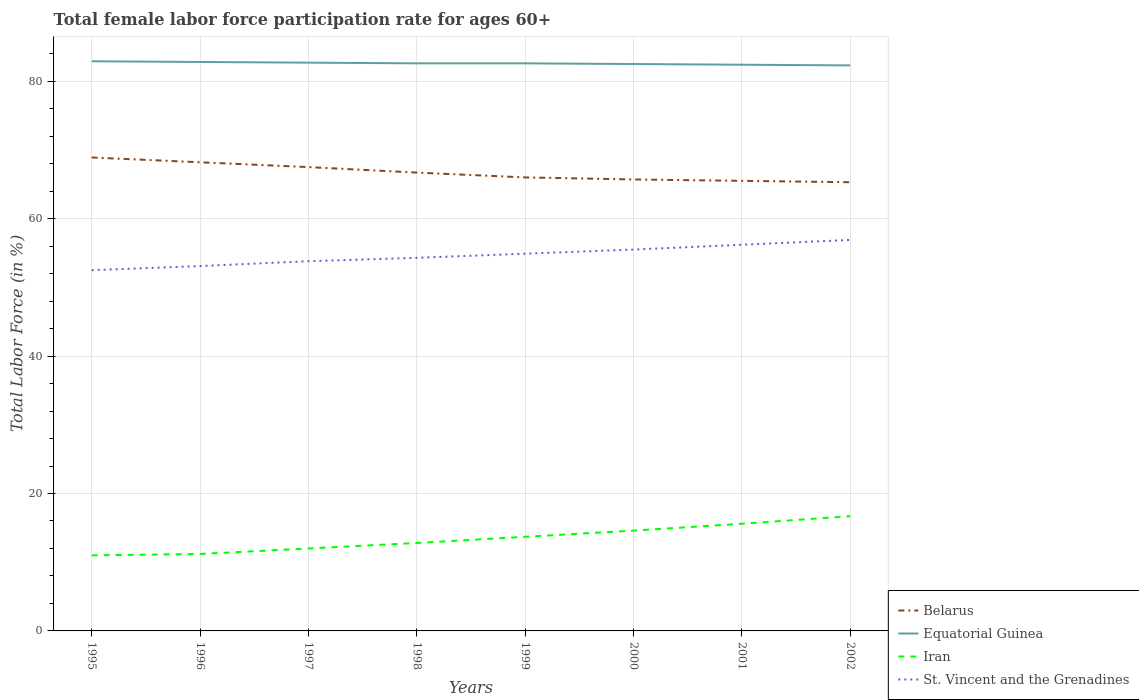How many different coloured lines are there?
Give a very brief answer. 4. Does the line corresponding to Iran intersect with the line corresponding to Belarus?
Provide a succinct answer. No. Is the number of lines equal to the number of legend labels?
Your response must be concise. Yes. Across all years, what is the maximum female labor force participation rate in Belarus?
Offer a terse response. 65.3. What is the total female labor force participation rate in St. Vincent and the Grenadines in the graph?
Provide a short and direct response. -0.6. What is the difference between the highest and the second highest female labor force participation rate in Equatorial Guinea?
Ensure brevity in your answer.  0.6. Is the female labor force participation rate in Equatorial Guinea strictly greater than the female labor force participation rate in St. Vincent and the Grenadines over the years?
Offer a very short reply. No. Are the values on the major ticks of Y-axis written in scientific E-notation?
Make the answer very short. No. Where does the legend appear in the graph?
Offer a very short reply. Bottom right. What is the title of the graph?
Ensure brevity in your answer.  Total female labor force participation rate for ages 60+. Does "South Sudan" appear as one of the legend labels in the graph?
Your answer should be very brief. No. What is the label or title of the Y-axis?
Provide a short and direct response. Total Labor Force (in %). What is the Total Labor Force (in %) of Belarus in 1995?
Offer a very short reply. 68.9. What is the Total Labor Force (in %) in Equatorial Guinea in 1995?
Give a very brief answer. 82.9. What is the Total Labor Force (in %) in Iran in 1995?
Offer a very short reply. 11. What is the Total Labor Force (in %) of St. Vincent and the Grenadines in 1995?
Your response must be concise. 52.5. What is the Total Labor Force (in %) of Belarus in 1996?
Make the answer very short. 68.2. What is the Total Labor Force (in %) in Equatorial Guinea in 1996?
Offer a terse response. 82.8. What is the Total Labor Force (in %) in Iran in 1996?
Keep it short and to the point. 11.2. What is the Total Labor Force (in %) of St. Vincent and the Grenadines in 1996?
Provide a short and direct response. 53.1. What is the Total Labor Force (in %) of Belarus in 1997?
Your answer should be compact. 67.5. What is the Total Labor Force (in %) of Equatorial Guinea in 1997?
Give a very brief answer. 82.7. What is the Total Labor Force (in %) in St. Vincent and the Grenadines in 1997?
Provide a succinct answer. 53.8. What is the Total Labor Force (in %) of Belarus in 1998?
Keep it short and to the point. 66.7. What is the Total Labor Force (in %) in Equatorial Guinea in 1998?
Ensure brevity in your answer.  82.6. What is the Total Labor Force (in %) in Iran in 1998?
Your answer should be compact. 12.8. What is the Total Labor Force (in %) of St. Vincent and the Grenadines in 1998?
Give a very brief answer. 54.3. What is the Total Labor Force (in %) in Equatorial Guinea in 1999?
Give a very brief answer. 82.6. What is the Total Labor Force (in %) of Iran in 1999?
Ensure brevity in your answer.  13.7. What is the Total Labor Force (in %) in St. Vincent and the Grenadines in 1999?
Offer a very short reply. 54.9. What is the Total Labor Force (in %) in Belarus in 2000?
Your response must be concise. 65.7. What is the Total Labor Force (in %) of Equatorial Guinea in 2000?
Your answer should be very brief. 82.5. What is the Total Labor Force (in %) of Iran in 2000?
Ensure brevity in your answer.  14.6. What is the Total Labor Force (in %) of St. Vincent and the Grenadines in 2000?
Offer a very short reply. 55.5. What is the Total Labor Force (in %) in Belarus in 2001?
Offer a terse response. 65.5. What is the Total Labor Force (in %) of Equatorial Guinea in 2001?
Your answer should be very brief. 82.4. What is the Total Labor Force (in %) in Iran in 2001?
Ensure brevity in your answer.  15.6. What is the Total Labor Force (in %) in St. Vincent and the Grenadines in 2001?
Your answer should be compact. 56.2. What is the Total Labor Force (in %) in Belarus in 2002?
Keep it short and to the point. 65.3. What is the Total Labor Force (in %) of Equatorial Guinea in 2002?
Provide a short and direct response. 82.3. What is the Total Labor Force (in %) of Iran in 2002?
Your answer should be compact. 16.7. What is the Total Labor Force (in %) in St. Vincent and the Grenadines in 2002?
Your answer should be very brief. 56.9. Across all years, what is the maximum Total Labor Force (in %) of Belarus?
Make the answer very short. 68.9. Across all years, what is the maximum Total Labor Force (in %) of Equatorial Guinea?
Offer a terse response. 82.9. Across all years, what is the maximum Total Labor Force (in %) of Iran?
Keep it short and to the point. 16.7. Across all years, what is the maximum Total Labor Force (in %) of St. Vincent and the Grenadines?
Ensure brevity in your answer.  56.9. Across all years, what is the minimum Total Labor Force (in %) of Belarus?
Ensure brevity in your answer.  65.3. Across all years, what is the minimum Total Labor Force (in %) in Equatorial Guinea?
Provide a succinct answer. 82.3. Across all years, what is the minimum Total Labor Force (in %) of St. Vincent and the Grenadines?
Offer a terse response. 52.5. What is the total Total Labor Force (in %) in Belarus in the graph?
Provide a succinct answer. 533.8. What is the total Total Labor Force (in %) of Equatorial Guinea in the graph?
Offer a very short reply. 660.8. What is the total Total Labor Force (in %) of Iran in the graph?
Offer a very short reply. 107.6. What is the total Total Labor Force (in %) in St. Vincent and the Grenadines in the graph?
Give a very brief answer. 437.2. What is the difference between the Total Labor Force (in %) of Equatorial Guinea in 1995 and that in 1997?
Provide a short and direct response. 0.2. What is the difference between the Total Labor Force (in %) in Iran in 1995 and that in 1997?
Make the answer very short. -1. What is the difference between the Total Labor Force (in %) of St. Vincent and the Grenadines in 1995 and that in 1997?
Make the answer very short. -1.3. What is the difference between the Total Labor Force (in %) in Iran in 1995 and that in 1998?
Provide a short and direct response. -1.8. What is the difference between the Total Labor Force (in %) in Equatorial Guinea in 1995 and that in 1999?
Keep it short and to the point. 0.3. What is the difference between the Total Labor Force (in %) in Iran in 1995 and that in 1999?
Your response must be concise. -2.7. What is the difference between the Total Labor Force (in %) in St. Vincent and the Grenadines in 1995 and that in 1999?
Keep it short and to the point. -2.4. What is the difference between the Total Labor Force (in %) in Iran in 1995 and that in 2000?
Make the answer very short. -3.6. What is the difference between the Total Labor Force (in %) of Belarus in 1995 and that in 2002?
Your answer should be very brief. 3.6. What is the difference between the Total Labor Force (in %) in Iran in 1996 and that in 1998?
Ensure brevity in your answer.  -1.6. What is the difference between the Total Labor Force (in %) of Equatorial Guinea in 1996 and that in 1999?
Ensure brevity in your answer.  0.2. What is the difference between the Total Labor Force (in %) in St. Vincent and the Grenadines in 1996 and that in 1999?
Ensure brevity in your answer.  -1.8. What is the difference between the Total Labor Force (in %) in Iran in 1996 and that in 2000?
Give a very brief answer. -3.4. What is the difference between the Total Labor Force (in %) of St. Vincent and the Grenadines in 1996 and that in 2000?
Offer a very short reply. -2.4. What is the difference between the Total Labor Force (in %) in Belarus in 1996 and that in 2001?
Make the answer very short. 2.7. What is the difference between the Total Labor Force (in %) in St. Vincent and the Grenadines in 1996 and that in 2002?
Provide a short and direct response. -3.8. What is the difference between the Total Labor Force (in %) of Equatorial Guinea in 1997 and that in 1998?
Make the answer very short. 0.1. What is the difference between the Total Labor Force (in %) in Belarus in 1997 and that in 1999?
Make the answer very short. 1.5. What is the difference between the Total Labor Force (in %) in Iran in 1997 and that in 1999?
Make the answer very short. -1.7. What is the difference between the Total Labor Force (in %) in St. Vincent and the Grenadines in 1997 and that in 1999?
Offer a terse response. -1.1. What is the difference between the Total Labor Force (in %) of Iran in 1997 and that in 2000?
Your answer should be very brief. -2.6. What is the difference between the Total Labor Force (in %) in St. Vincent and the Grenadines in 1997 and that in 2000?
Offer a very short reply. -1.7. What is the difference between the Total Labor Force (in %) in Belarus in 1997 and that in 2001?
Provide a succinct answer. 2. What is the difference between the Total Labor Force (in %) in Iran in 1997 and that in 2001?
Your response must be concise. -3.6. What is the difference between the Total Labor Force (in %) in Belarus in 1997 and that in 2002?
Ensure brevity in your answer.  2.2. What is the difference between the Total Labor Force (in %) of St. Vincent and the Grenadines in 1997 and that in 2002?
Provide a succinct answer. -3.1. What is the difference between the Total Labor Force (in %) of Belarus in 1998 and that in 1999?
Provide a short and direct response. 0.7. What is the difference between the Total Labor Force (in %) in Iran in 1998 and that in 1999?
Your response must be concise. -0.9. What is the difference between the Total Labor Force (in %) in St. Vincent and the Grenadines in 1998 and that in 1999?
Give a very brief answer. -0.6. What is the difference between the Total Labor Force (in %) in Belarus in 1998 and that in 2000?
Give a very brief answer. 1. What is the difference between the Total Labor Force (in %) in Equatorial Guinea in 1998 and that in 2000?
Offer a terse response. 0.1. What is the difference between the Total Labor Force (in %) in St. Vincent and the Grenadines in 1998 and that in 2000?
Your response must be concise. -1.2. What is the difference between the Total Labor Force (in %) of Belarus in 1998 and that in 2002?
Provide a short and direct response. 1.4. What is the difference between the Total Labor Force (in %) of Belarus in 1999 and that in 2000?
Give a very brief answer. 0.3. What is the difference between the Total Labor Force (in %) in Iran in 1999 and that in 2000?
Make the answer very short. -0.9. What is the difference between the Total Labor Force (in %) of Belarus in 1999 and that in 2001?
Make the answer very short. 0.5. What is the difference between the Total Labor Force (in %) of Iran in 1999 and that in 2001?
Make the answer very short. -1.9. What is the difference between the Total Labor Force (in %) in Belarus in 1999 and that in 2002?
Offer a terse response. 0.7. What is the difference between the Total Labor Force (in %) of St. Vincent and the Grenadines in 1999 and that in 2002?
Make the answer very short. -2. What is the difference between the Total Labor Force (in %) of Belarus in 2000 and that in 2001?
Provide a short and direct response. 0.2. What is the difference between the Total Labor Force (in %) of Equatorial Guinea in 2000 and that in 2001?
Provide a short and direct response. 0.1. What is the difference between the Total Labor Force (in %) in St. Vincent and the Grenadines in 2000 and that in 2001?
Your answer should be very brief. -0.7. What is the difference between the Total Labor Force (in %) of Belarus in 2000 and that in 2002?
Your answer should be very brief. 0.4. What is the difference between the Total Labor Force (in %) of Equatorial Guinea in 2000 and that in 2002?
Provide a succinct answer. 0.2. What is the difference between the Total Labor Force (in %) of Equatorial Guinea in 2001 and that in 2002?
Ensure brevity in your answer.  0.1. What is the difference between the Total Labor Force (in %) in Belarus in 1995 and the Total Labor Force (in %) in Iran in 1996?
Offer a very short reply. 57.7. What is the difference between the Total Labor Force (in %) in Equatorial Guinea in 1995 and the Total Labor Force (in %) in Iran in 1996?
Your answer should be very brief. 71.7. What is the difference between the Total Labor Force (in %) in Equatorial Guinea in 1995 and the Total Labor Force (in %) in St. Vincent and the Grenadines in 1996?
Offer a very short reply. 29.8. What is the difference between the Total Labor Force (in %) of Iran in 1995 and the Total Labor Force (in %) of St. Vincent and the Grenadines in 1996?
Provide a succinct answer. -42.1. What is the difference between the Total Labor Force (in %) of Belarus in 1995 and the Total Labor Force (in %) of Equatorial Guinea in 1997?
Provide a short and direct response. -13.8. What is the difference between the Total Labor Force (in %) of Belarus in 1995 and the Total Labor Force (in %) of Iran in 1997?
Provide a short and direct response. 56.9. What is the difference between the Total Labor Force (in %) in Belarus in 1995 and the Total Labor Force (in %) in St. Vincent and the Grenadines in 1997?
Give a very brief answer. 15.1. What is the difference between the Total Labor Force (in %) in Equatorial Guinea in 1995 and the Total Labor Force (in %) in Iran in 1997?
Keep it short and to the point. 70.9. What is the difference between the Total Labor Force (in %) of Equatorial Guinea in 1995 and the Total Labor Force (in %) of St. Vincent and the Grenadines in 1997?
Keep it short and to the point. 29.1. What is the difference between the Total Labor Force (in %) of Iran in 1995 and the Total Labor Force (in %) of St. Vincent and the Grenadines in 1997?
Your answer should be very brief. -42.8. What is the difference between the Total Labor Force (in %) of Belarus in 1995 and the Total Labor Force (in %) of Equatorial Guinea in 1998?
Provide a short and direct response. -13.7. What is the difference between the Total Labor Force (in %) in Belarus in 1995 and the Total Labor Force (in %) in Iran in 1998?
Your answer should be compact. 56.1. What is the difference between the Total Labor Force (in %) of Belarus in 1995 and the Total Labor Force (in %) of St. Vincent and the Grenadines in 1998?
Your response must be concise. 14.6. What is the difference between the Total Labor Force (in %) in Equatorial Guinea in 1995 and the Total Labor Force (in %) in Iran in 1998?
Your answer should be compact. 70.1. What is the difference between the Total Labor Force (in %) in Equatorial Guinea in 1995 and the Total Labor Force (in %) in St. Vincent and the Grenadines in 1998?
Offer a terse response. 28.6. What is the difference between the Total Labor Force (in %) in Iran in 1995 and the Total Labor Force (in %) in St. Vincent and the Grenadines in 1998?
Your answer should be compact. -43.3. What is the difference between the Total Labor Force (in %) in Belarus in 1995 and the Total Labor Force (in %) in Equatorial Guinea in 1999?
Your answer should be very brief. -13.7. What is the difference between the Total Labor Force (in %) of Belarus in 1995 and the Total Labor Force (in %) of Iran in 1999?
Ensure brevity in your answer.  55.2. What is the difference between the Total Labor Force (in %) of Equatorial Guinea in 1995 and the Total Labor Force (in %) of Iran in 1999?
Offer a very short reply. 69.2. What is the difference between the Total Labor Force (in %) of Equatorial Guinea in 1995 and the Total Labor Force (in %) of St. Vincent and the Grenadines in 1999?
Provide a short and direct response. 28. What is the difference between the Total Labor Force (in %) of Iran in 1995 and the Total Labor Force (in %) of St. Vincent and the Grenadines in 1999?
Make the answer very short. -43.9. What is the difference between the Total Labor Force (in %) of Belarus in 1995 and the Total Labor Force (in %) of Equatorial Guinea in 2000?
Your answer should be very brief. -13.6. What is the difference between the Total Labor Force (in %) in Belarus in 1995 and the Total Labor Force (in %) in Iran in 2000?
Your answer should be compact. 54.3. What is the difference between the Total Labor Force (in %) in Belarus in 1995 and the Total Labor Force (in %) in St. Vincent and the Grenadines in 2000?
Ensure brevity in your answer.  13.4. What is the difference between the Total Labor Force (in %) in Equatorial Guinea in 1995 and the Total Labor Force (in %) in Iran in 2000?
Ensure brevity in your answer.  68.3. What is the difference between the Total Labor Force (in %) in Equatorial Guinea in 1995 and the Total Labor Force (in %) in St. Vincent and the Grenadines in 2000?
Ensure brevity in your answer.  27.4. What is the difference between the Total Labor Force (in %) in Iran in 1995 and the Total Labor Force (in %) in St. Vincent and the Grenadines in 2000?
Offer a very short reply. -44.5. What is the difference between the Total Labor Force (in %) in Belarus in 1995 and the Total Labor Force (in %) in Equatorial Guinea in 2001?
Offer a terse response. -13.5. What is the difference between the Total Labor Force (in %) of Belarus in 1995 and the Total Labor Force (in %) of Iran in 2001?
Give a very brief answer. 53.3. What is the difference between the Total Labor Force (in %) of Equatorial Guinea in 1995 and the Total Labor Force (in %) of Iran in 2001?
Your answer should be very brief. 67.3. What is the difference between the Total Labor Force (in %) in Equatorial Guinea in 1995 and the Total Labor Force (in %) in St. Vincent and the Grenadines in 2001?
Keep it short and to the point. 26.7. What is the difference between the Total Labor Force (in %) of Iran in 1995 and the Total Labor Force (in %) of St. Vincent and the Grenadines in 2001?
Provide a succinct answer. -45.2. What is the difference between the Total Labor Force (in %) in Belarus in 1995 and the Total Labor Force (in %) in Equatorial Guinea in 2002?
Make the answer very short. -13.4. What is the difference between the Total Labor Force (in %) in Belarus in 1995 and the Total Labor Force (in %) in Iran in 2002?
Keep it short and to the point. 52.2. What is the difference between the Total Labor Force (in %) in Equatorial Guinea in 1995 and the Total Labor Force (in %) in Iran in 2002?
Offer a very short reply. 66.2. What is the difference between the Total Labor Force (in %) of Iran in 1995 and the Total Labor Force (in %) of St. Vincent and the Grenadines in 2002?
Keep it short and to the point. -45.9. What is the difference between the Total Labor Force (in %) in Belarus in 1996 and the Total Labor Force (in %) in Iran in 1997?
Make the answer very short. 56.2. What is the difference between the Total Labor Force (in %) of Equatorial Guinea in 1996 and the Total Labor Force (in %) of Iran in 1997?
Keep it short and to the point. 70.8. What is the difference between the Total Labor Force (in %) in Equatorial Guinea in 1996 and the Total Labor Force (in %) in St. Vincent and the Grenadines in 1997?
Provide a succinct answer. 29. What is the difference between the Total Labor Force (in %) in Iran in 1996 and the Total Labor Force (in %) in St. Vincent and the Grenadines in 1997?
Give a very brief answer. -42.6. What is the difference between the Total Labor Force (in %) of Belarus in 1996 and the Total Labor Force (in %) of Equatorial Guinea in 1998?
Keep it short and to the point. -14.4. What is the difference between the Total Labor Force (in %) of Belarus in 1996 and the Total Labor Force (in %) of Iran in 1998?
Provide a short and direct response. 55.4. What is the difference between the Total Labor Force (in %) in Belarus in 1996 and the Total Labor Force (in %) in St. Vincent and the Grenadines in 1998?
Make the answer very short. 13.9. What is the difference between the Total Labor Force (in %) of Equatorial Guinea in 1996 and the Total Labor Force (in %) of Iran in 1998?
Offer a very short reply. 70. What is the difference between the Total Labor Force (in %) in Iran in 1996 and the Total Labor Force (in %) in St. Vincent and the Grenadines in 1998?
Keep it short and to the point. -43.1. What is the difference between the Total Labor Force (in %) of Belarus in 1996 and the Total Labor Force (in %) of Equatorial Guinea in 1999?
Offer a terse response. -14.4. What is the difference between the Total Labor Force (in %) of Belarus in 1996 and the Total Labor Force (in %) of Iran in 1999?
Make the answer very short. 54.5. What is the difference between the Total Labor Force (in %) of Belarus in 1996 and the Total Labor Force (in %) of St. Vincent and the Grenadines in 1999?
Offer a very short reply. 13.3. What is the difference between the Total Labor Force (in %) in Equatorial Guinea in 1996 and the Total Labor Force (in %) in Iran in 1999?
Ensure brevity in your answer.  69.1. What is the difference between the Total Labor Force (in %) in Equatorial Guinea in 1996 and the Total Labor Force (in %) in St. Vincent and the Grenadines in 1999?
Give a very brief answer. 27.9. What is the difference between the Total Labor Force (in %) of Iran in 1996 and the Total Labor Force (in %) of St. Vincent and the Grenadines in 1999?
Provide a short and direct response. -43.7. What is the difference between the Total Labor Force (in %) of Belarus in 1996 and the Total Labor Force (in %) of Equatorial Guinea in 2000?
Keep it short and to the point. -14.3. What is the difference between the Total Labor Force (in %) of Belarus in 1996 and the Total Labor Force (in %) of Iran in 2000?
Ensure brevity in your answer.  53.6. What is the difference between the Total Labor Force (in %) of Belarus in 1996 and the Total Labor Force (in %) of St. Vincent and the Grenadines in 2000?
Your answer should be compact. 12.7. What is the difference between the Total Labor Force (in %) of Equatorial Guinea in 1996 and the Total Labor Force (in %) of Iran in 2000?
Ensure brevity in your answer.  68.2. What is the difference between the Total Labor Force (in %) in Equatorial Guinea in 1996 and the Total Labor Force (in %) in St. Vincent and the Grenadines in 2000?
Ensure brevity in your answer.  27.3. What is the difference between the Total Labor Force (in %) in Iran in 1996 and the Total Labor Force (in %) in St. Vincent and the Grenadines in 2000?
Make the answer very short. -44.3. What is the difference between the Total Labor Force (in %) of Belarus in 1996 and the Total Labor Force (in %) of Equatorial Guinea in 2001?
Your answer should be very brief. -14.2. What is the difference between the Total Labor Force (in %) of Belarus in 1996 and the Total Labor Force (in %) of Iran in 2001?
Offer a very short reply. 52.6. What is the difference between the Total Labor Force (in %) of Belarus in 1996 and the Total Labor Force (in %) of St. Vincent and the Grenadines in 2001?
Keep it short and to the point. 12. What is the difference between the Total Labor Force (in %) in Equatorial Guinea in 1996 and the Total Labor Force (in %) in Iran in 2001?
Make the answer very short. 67.2. What is the difference between the Total Labor Force (in %) in Equatorial Guinea in 1996 and the Total Labor Force (in %) in St. Vincent and the Grenadines in 2001?
Keep it short and to the point. 26.6. What is the difference between the Total Labor Force (in %) of Iran in 1996 and the Total Labor Force (in %) of St. Vincent and the Grenadines in 2001?
Provide a succinct answer. -45. What is the difference between the Total Labor Force (in %) in Belarus in 1996 and the Total Labor Force (in %) in Equatorial Guinea in 2002?
Make the answer very short. -14.1. What is the difference between the Total Labor Force (in %) in Belarus in 1996 and the Total Labor Force (in %) in Iran in 2002?
Provide a succinct answer. 51.5. What is the difference between the Total Labor Force (in %) in Belarus in 1996 and the Total Labor Force (in %) in St. Vincent and the Grenadines in 2002?
Your response must be concise. 11.3. What is the difference between the Total Labor Force (in %) of Equatorial Guinea in 1996 and the Total Labor Force (in %) of Iran in 2002?
Your answer should be compact. 66.1. What is the difference between the Total Labor Force (in %) in Equatorial Guinea in 1996 and the Total Labor Force (in %) in St. Vincent and the Grenadines in 2002?
Offer a terse response. 25.9. What is the difference between the Total Labor Force (in %) of Iran in 1996 and the Total Labor Force (in %) of St. Vincent and the Grenadines in 2002?
Ensure brevity in your answer.  -45.7. What is the difference between the Total Labor Force (in %) of Belarus in 1997 and the Total Labor Force (in %) of Equatorial Guinea in 1998?
Your answer should be compact. -15.1. What is the difference between the Total Labor Force (in %) of Belarus in 1997 and the Total Labor Force (in %) of Iran in 1998?
Ensure brevity in your answer.  54.7. What is the difference between the Total Labor Force (in %) in Belarus in 1997 and the Total Labor Force (in %) in St. Vincent and the Grenadines in 1998?
Offer a terse response. 13.2. What is the difference between the Total Labor Force (in %) of Equatorial Guinea in 1997 and the Total Labor Force (in %) of Iran in 1998?
Make the answer very short. 69.9. What is the difference between the Total Labor Force (in %) of Equatorial Guinea in 1997 and the Total Labor Force (in %) of St. Vincent and the Grenadines in 1998?
Give a very brief answer. 28.4. What is the difference between the Total Labor Force (in %) in Iran in 1997 and the Total Labor Force (in %) in St. Vincent and the Grenadines in 1998?
Provide a succinct answer. -42.3. What is the difference between the Total Labor Force (in %) in Belarus in 1997 and the Total Labor Force (in %) in Equatorial Guinea in 1999?
Provide a short and direct response. -15.1. What is the difference between the Total Labor Force (in %) of Belarus in 1997 and the Total Labor Force (in %) of Iran in 1999?
Provide a succinct answer. 53.8. What is the difference between the Total Labor Force (in %) of Equatorial Guinea in 1997 and the Total Labor Force (in %) of Iran in 1999?
Give a very brief answer. 69. What is the difference between the Total Labor Force (in %) of Equatorial Guinea in 1997 and the Total Labor Force (in %) of St. Vincent and the Grenadines in 1999?
Your answer should be very brief. 27.8. What is the difference between the Total Labor Force (in %) of Iran in 1997 and the Total Labor Force (in %) of St. Vincent and the Grenadines in 1999?
Keep it short and to the point. -42.9. What is the difference between the Total Labor Force (in %) in Belarus in 1997 and the Total Labor Force (in %) in Iran in 2000?
Keep it short and to the point. 52.9. What is the difference between the Total Labor Force (in %) of Equatorial Guinea in 1997 and the Total Labor Force (in %) of Iran in 2000?
Make the answer very short. 68.1. What is the difference between the Total Labor Force (in %) in Equatorial Guinea in 1997 and the Total Labor Force (in %) in St. Vincent and the Grenadines in 2000?
Offer a terse response. 27.2. What is the difference between the Total Labor Force (in %) of Iran in 1997 and the Total Labor Force (in %) of St. Vincent and the Grenadines in 2000?
Your answer should be compact. -43.5. What is the difference between the Total Labor Force (in %) of Belarus in 1997 and the Total Labor Force (in %) of Equatorial Guinea in 2001?
Provide a short and direct response. -14.9. What is the difference between the Total Labor Force (in %) in Belarus in 1997 and the Total Labor Force (in %) in Iran in 2001?
Your answer should be very brief. 51.9. What is the difference between the Total Labor Force (in %) of Belarus in 1997 and the Total Labor Force (in %) of St. Vincent and the Grenadines in 2001?
Ensure brevity in your answer.  11.3. What is the difference between the Total Labor Force (in %) in Equatorial Guinea in 1997 and the Total Labor Force (in %) in Iran in 2001?
Your response must be concise. 67.1. What is the difference between the Total Labor Force (in %) in Equatorial Guinea in 1997 and the Total Labor Force (in %) in St. Vincent and the Grenadines in 2001?
Offer a terse response. 26.5. What is the difference between the Total Labor Force (in %) in Iran in 1997 and the Total Labor Force (in %) in St. Vincent and the Grenadines in 2001?
Provide a short and direct response. -44.2. What is the difference between the Total Labor Force (in %) in Belarus in 1997 and the Total Labor Force (in %) in Equatorial Guinea in 2002?
Your answer should be compact. -14.8. What is the difference between the Total Labor Force (in %) in Belarus in 1997 and the Total Labor Force (in %) in Iran in 2002?
Keep it short and to the point. 50.8. What is the difference between the Total Labor Force (in %) in Belarus in 1997 and the Total Labor Force (in %) in St. Vincent and the Grenadines in 2002?
Give a very brief answer. 10.6. What is the difference between the Total Labor Force (in %) in Equatorial Guinea in 1997 and the Total Labor Force (in %) in St. Vincent and the Grenadines in 2002?
Keep it short and to the point. 25.8. What is the difference between the Total Labor Force (in %) in Iran in 1997 and the Total Labor Force (in %) in St. Vincent and the Grenadines in 2002?
Keep it short and to the point. -44.9. What is the difference between the Total Labor Force (in %) in Belarus in 1998 and the Total Labor Force (in %) in Equatorial Guinea in 1999?
Ensure brevity in your answer.  -15.9. What is the difference between the Total Labor Force (in %) of Belarus in 1998 and the Total Labor Force (in %) of Iran in 1999?
Offer a terse response. 53. What is the difference between the Total Labor Force (in %) in Belarus in 1998 and the Total Labor Force (in %) in St. Vincent and the Grenadines in 1999?
Offer a very short reply. 11.8. What is the difference between the Total Labor Force (in %) in Equatorial Guinea in 1998 and the Total Labor Force (in %) in Iran in 1999?
Ensure brevity in your answer.  68.9. What is the difference between the Total Labor Force (in %) of Equatorial Guinea in 1998 and the Total Labor Force (in %) of St. Vincent and the Grenadines in 1999?
Keep it short and to the point. 27.7. What is the difference between the Total Labor Force (in %) in Iran in 1998 and the Total Labor Force (in %) in St. Vincent and the Grenadines in 1999?
Offer a terse response. -42.1. What is the difference between the Total Labor Force (in %) of Belarus in 1998 and the Total Labor Force (in %) of Equatorial Guinea in 2000?
Give a very brief answer. -15.8. What is the difference between the Total Labor Force (in %) in Belarus in 1998 and the Total Labor Force (in %) in Iran in 2000?
Provide a short and direct response. 52.1. What is the difference between the Total Labor Force (in %) of Equatorial Guinea in 1998 and the Total Labor Force (in %) of Iran in 2000?
Provide a short and direct response. 68. What is the difference between the Total Labor Force (in %) of Equatorial Guinea in 1998 and the Total Labor Force (in %) of St. Vincent and the Grenadines in 2000?
Ensure brevity in your answer.  27.1. What is the difference between the Total Labor Force (in %) of Iran in 1998 and the Total Labor Force (in %) of St. Vincent and the Grenadines in 2000?
Keep it short and to the point. -42.7. What is the difference between the Total Labor Force (in %) of Belarus in 1998 and the Total Labor Force (in %) of Equatorial Guinea in 2001?
Give a very brief answer. -15.7. What is the difference between the Total Labor Force (in %) of Belarus in 1998 and the Total Labor Force (in %) of Iran in 2001?
Ensure brevity in your answer.  51.1. What is the difference between the Total Labor Force (in %) of Belarus in 1998 and the Total Labor Force (in %) of St. Vincent and the Grenadines in 2001?
Provide a short and direct response. 10.5. What is the difference between the Total Labor Force (in %) in Equatorial Guinea in 1998 and the Total Labor Force (in %) in St. Vincent and the Grenadines in 2001?
Keep it short and to the point. 26.4. What is the difference between the Total Labor Force (in %) of Iran in 1998 and the Total Labor Force (in %) of St. Vincent and the Grenadines in 2001?
Provide a succinct answer. -43.4. What is the difference between the Total Labor Force (in %) of Belarus in 1998 and the Total Labor Force (in %) of Equatorial Guinea in 2002?
Make the answer very short. -15.6. What is the difference between the Total Labor Force (in %) in Belarus in 1998 and the Total Labor Force (in %) in St. Vincent and the Grenadines in 2002?
Make the answer very short. 9.8. What is the difference between the Total Labor Force (in %) of Equatorial Guinea in 1998 and the Total Labor Force (in %) of Iran in 2002?
Your response must be concise. 65.9. What is the difference between the Total Labor Force (in %) in Equatorial Guinea in 1998 and the Total Labor Force (in %) in St. Vincent and the Grenadines in 2002?
Offer a very short reply. 25.7. What is the difference between the Total Labor Force (in %) of Iran in 1998 and the Total Labor Force (in %) of St. Vincent and the Grenadines in 2002?
Provide a short and direct response. -44.1. What is the difference between the Total Labor Force (in %) in Belarus in 1999 and the Total Labor Force (in %) in Equatorial Guinea in 2000?
Give a very brief answer. -16.5. What is the difference between the Total Labor Force (in %) in Belarus in 1999 and the Total Labor Force (in %) in Iran in 2000?
Make the answer very short. 51.4. What is the difference between the Total Labor Force (in %) of Belarus in 1999 and the Total Labor Force (in %) of St. Vincent and the Grenadines in 2000?
Provide a succinct answer. 10.5. What is the difference between the Total Labor Force (in %) in Equatorial Guinea in 1999 and the Total Labor Force (in %) in St. Vincent and the Grenadines in 2000?
Provide a succinct answer. 27.1. What is the difference between the Total Labor Force (in %) of Iran in 1999 and the Total Labor Force (in %) of St. Vincent and the Grenadines in 2000?
Provide a short and direct response. -41.8. What is the difference between the Total Labor Force (in %) in Belarus in 1999 and the Total Labor Force (in %) in Equatorial Guinea in 2001?
Your response must be concise. -16.4. What is the difference between the Total Labor Force (in %) of Belarus in 1999 and the Total Labor Force (in %) of Iran in 2001?
Provide a succinct answer. 50.4. What is the difference between the Total Labor Force (in %) of Equatorial Guinea in 1999 and the Total Labor Force (in %) of St. Vincent and the Grenadines in 2001?
Ensure brevity in your answer.  26.4. What is the difference between the Total Labor Force (in %) in Iran in 1999 and the Total Labor Force (in %) in St. Vincent and the Grenadines in 2001?
Provide a short and direct response. -42.5. What is the difference between the Total Labor Force (in %) of Belarus in 1999 and the Total Labor Force (in %) of Equatorial Guinea in 2002?
Ensure brevity in your answer.  -16.3. What is the difference between the Total Labor Force (in %) in Belarus in 1999 and the Total Labor Force (in %) in Iran in 2002?
Keep it short and to the point. 49.3. What is the difference between the Total Labor Force (in %) in Equatorial Guinea in 1999 and the Total Labor Force (in %) in Iran in 2002?
Make the answer very short. 65.9. What is the difference between the Total Labor Force (in %) of Equatorial Guinea in 1999 and the Total Labor Force (in %) of St. Vincent and the Grenadines in 2002?
Your response must be concise. 25.7. What is the difference between the Total Labor Force (in %) of Iran in 1999 and the Total Labor Force (in %) of St. Vincent and the Grenadines in 2002?
Your answer should be compact. -43.2. What is the difference between the Total Labor Force (in %) in Belarus in 2000 and the Total Labor Force (in %) in Equatorial Guinea in 2001?
Your answer should be compact. -16.7. What is the difference between the Total Labor Force (in %) of Belarus in 2000 and the Total Labor Force (in %) of Iran in 2001?
Give a very brief answer. 50.1. What is the difference between the Total Labor Force (in %) of Belarus in 2000 and the Total Labor Force (in %) of St. Vincent and the Grenadines in 2001?
Provide a short and direct response. 9.5. What is the difference between the Total Labor Force (in %) in Equatorial Guinea in 2000 and the Total Labor Force (in %) in Iran in 2001?
Your answer should be compact. 66.9. What is the difference between the Total Labor Force (in %) in Equatorial Guinea in 2000 and the Total Labor Force (in %) in St. Vincent and the Grenadines in 2001?
Offer a terse response. 26.3. What is the difference between the Total Labor Force (in %) of Iran in 2000 and the Total Labor Force (in %) of St. Vincent and the Grenadines in 2001?
Your answer should be very brief. -41.6. What is the difference between the Total Labor Force (in %) of Belarus in 2000 and the Total Labor Force (in %) of Equatorial Guinea in 2002?
Give a very brief answer. -16.6. What is the difference between the Total Labor Force (in %) of Belarus in 2000 and the Total Labor Force (in %) of Iran in 2002?
Make the answer very short. 49. What is the difference between the Total Labor Force (in %) of Belarus in 2000 and the Total Labor Force (in %) of St. Vincent and the Grenadines in 2002?
Provide a short and direct response. 8.8. What is the difference between the Total Labor Force (in %) of Equatorial Guinea in 2000 and the Total Labor Force (in %) of Iran in 2002?
Provide a short and direct response. 65.8. What is the difference between the Total Labor Force (in %) of Equatorial Guinea in 2000 and the Total Labor Force (in %) of St. Vincent and the Grenadines in 2002?
Give a very brief answer. 25.6. What is the difference between the Total Labor Force (in %) of Iran in 2000 and the Total Labor Force (in %) of St. Vincent and the Grenadines in 2002?
Keep it short and to the point. -42.3. What is the difference between the Total Labor Force (in %) in Belarus in 2001 and the Total Labor Force (in %) in Equatorial Guinea in 2002?
Provide a short and direct response. -16.8. What is the difference between the Total Labor Force (in %) in Belarus in 2001 and the Total Labor Force (in %) in Iran in 2002?
Your answer should be compact. 48.8. What is the difference between the Total Labor Force (in %) of Belarus in 2001 and the Total Labor Force (in %) of St. Vincent and the Grenadines in 2002?
Your answer should be compact. 8.6. What is the difference between the Total Labor Force (in %) in Equatorial Guinea in 2001 and the Total Labor Force (in %) in Iran in 2002?
Your answer should be compact. 65.7. What is the difference between the Total Labor Force (in %) in Iran in 2001 and the Total Labor Force (in %) in St. Vincent and the Grenadines in 2002?
Your response must be concise. -41.3. What is the average Total Labor Force (in %) of Belarus per year?
Your answer should be very brief. 66.72. What is the average Total Labor Force (in %) of Equatorial Guinea per year?
Make the answer very short. 82.6. What is the average Total Labor Force (in %) of Iran per year?
Offer a terse response. 13.45. What is the average Total Labor Force (in %) in St. Vincent and the Grenadines per year?
Your answer should be compact. 54.65. In the year 1995, what is the difference between the Total Labor Force (in %) of Belarus and Total Labor Force (in %) of Iran?
Make the answer very short. 57.9. In the year 1995, what is the difference between the Total Labor Force (in %) in Belarus and Total Labor Force (in %) in St. Vincent and the Grenadines?
Give a very brief answer. 16.4. In the year 1995, what is the difference between the Total Labor Force (in %) in Equatorial Guinea and Total Labor Force (in %) in Iran?
Keep it short and to the point. 71.9. In the year 1995, what is the difference between the Total Labor Force (in %) of Equatorial Guinea and Total Labor Force (in %) of St. Vincent and the Grenadines?
Your response must be concise. 30.4. In the year 1995, what is the difference between the Total Labor Force (in %) in Iran and Total Labor Force (in %) in St. Vincent and the Grenadines?
Keep it short and to the point. -41.5. In the year 1996, what is the difference between the Total Labor Force (in %) of Belarus and Total Labor Force (in %) of Equatorial Guinea?
Your answer should be very brief. -14.6. In the year 1996, what is the difference between the Total Labor Force (in %) in Belarus and Total Labor Force (in %) in Iran?
Provide a short and direct response. 57. In the year 1996, what is the difference between the Total Labor Force (in %) of Belarus and Total Labor Force (in %) of St. Vincent and the Grenadines?
Your answer should be very brief. 15.1. In the year 1996, what is the difference between the Total Labor Force (in %) in Equatorial Guinea and Total Labor Force (in %) in Iran?
Your response must be concise. 71.6. In the year 1996, what is the difference between the Total Labor Force (in %) in Equatorial Guinea and Total Labor Force (in %) in St. Vincent and the Grenadines?
Provide a succinct answer. 29.7. In the year 1996, what is the difference between the Total Labor Force (in %) of Iran and Total Labor Force (in %) of St. Vincent and the Grenadines?
Your response must be concise. -41.9. In the year 1997, what is the difference between the Total Labor Force (in %) of Belarus and Total Labor Force (in %) of Equatorial Guinea?
Provide a short and direct response. -15.2. In the year 1997, what is the difference between the Total Labor Force (in %) of Belarus and Total Labor Force (in %) of Iran?
Your answer should be very brief. 55.5. In the year 1997, what is the difference between the Total Labor Force (in %) in Belarus and Total Labor Force (in %) in St. Vincent and the Grenadines?
Offer a very short reply. 13.7. In the year 1997, what is the difference between the Total Labor Force (in %) of Equatorial Guinea and Total Labor Force (in %) of Iran?
Ensure brevity in your answer.  70.7. In the year 1997, what is the difference between the Total Labor Force (in %) of Equatorial Guinea and Total Labor Force (in %) of St. Vincent and the Grenadines?
Provide a succinct answer. 28.9. In the year 1997, what is the difference between the Total Labor Force (in %) in Iran and Total Labor Force (in %) in St. Vincent and the Grenadines?
Make the answer very short. -41.8. In the year 1998, what is the difference between the Total Labor Force (in %) in Belarus and Total Labor Force (in %) in Equatorial Guinea?
Keep it short and to the point. -15.9. In the year 1998, what is the difference between the Total Labor Force (in %) in Belarus and Total Labor Force (in %) in Iran?
Offer a very short reply. 53.9. In the year 1998, what is the difference between the Total Labor Force (in %) in Equatorial Guinea and Total Labor Force (in %) in Iran?
Make the answer very short. 69.8. In the year 1998, what is the difference between the Total Labor Force (in %) of Equatorial Guinea and Total Labor Force (in %) of St. Vincent and the Grenadines?
Provide a short and direct response. 28.3. In the year 1998, what is the difference between the Total Labor Force (in %) of Iran and Total Labor Force (in %) of St. Vincent and the Grenadines?
Offer a terse response. -41.5. In the year 1999, what is the difference between the Total Labor Force (in %) of Belarus and Total Labor Force (in %) of Equatorial Guinea?
Your answer should be compact. -16.6. In the year 1999, what is the difference between the Total Labor Force (in %) of Belarus and Total Labor Force (in %) of Iran?
Your answer should be very brief. 52.3. In the year 1999, what is the difference between the Total Labor Force (in %) of Equatorial Guinea and Total Labor Force (in %) of Iran?
Your answer should be compact. 68.9. In the year 1999, what is the difference between the Total Labor Force (in %) of Equatorial Guinea and Total Labor Force (in %) of St. Vincent and the Grenadines?
Provide a succinct answer. 27.7. In the year 1999, what is the difference between the Total Labor Force (in %) of Iran and Total Labor Force (in %) of St. Vincent and the Grenadines?
Make the answer very short. -41.2. In the year 2000, what is the difference between the Total Labor Force (in %) of Belarus and Total Labor Force (in %) of Equatorial Guinea?
Give a very brief answer. -16.8. In the year 2000, what is the difference between the Total Labor Force (in %) of Belarus and Total Labor Force (in %) of Iran?
Provide a short and direct response. 51.1. In the year 2000, what is the difference between the Total Labor Force (in %) in Belarus and Total Labor Force (in %) in St. Vincent and the Grenadines?
Offer a terse response. 10.2. In the year 2000, what is the difference between the Total Labor Force (in %) in Equatorial Guinea and Total Labor Force (in %) in Iran?
Make the answer very short. 67.9. In the year 2000, what is the difference between the Total Labor Force (in %) in Equatorial Guinea and Total Labor Force (in %) in St. Vincent and the Grenadines?
Ensure brevity in your answer.  27. In the year 2000, what is the difference between the Total Labor Force (in %) in Iran and Total Labor Force (in %) in St. Vincent and the Grenadines?
Ensure brevity in your answer.  -40.9. In the year 2001, what is the difference between the Total Labor Force (in %) in Belarus and Total Labor Force (in %) in Equatorial Guinea?
Your answer should be compact. -16.9. In the year 2001, what is the difference between the Total Labor Force (in %) in Belarus and Total Labor Force (in %) in Iran?
Offer a terse response. 49.9. In the year 2001, what is the difference between the Total Labor Force (in %) in Equatorial Guinea and Total Labor Force (in %) in Iran?
Keep it short and to the point. 66.8. In the year 2001, what is the difference between the Total Labor Force (in %) in Equatorial Guinea and Total Labor Force (in %) in St. Vincent and the Grenadines?
Ensure brevity in your answer.  26.2. In the year 2001, what is the difference between the Total Labor Force (in %) in Iran and Total Labor Force (in %) in St. Vincent and the Grenadines?
Offer a terse response. -40.6. In the year 2002, what is the difference between the Total Labor Force (in %) of Belarus and Total Labor Force (in %) of Iran?
Your answer should be compact. 48.6. In the year 2002, what is the difference between the Total Labor Force (in %) in Equatorial Guinea and Total Labor Force (in %) in Iran?
Ensure brevity in your answer.  65.6. In the year 2002, what is the difference between the Total Labor Force (in %) in Equatorial Guinea and Total Labor Force (in %) in St. Vincent and the Grenadines?
Offer a terse response. 25.4. In the year 2002, what is the difference between the Total Labor Force (in %) in Iran and Total Labor Force (in %) in St. Vincent and the Grenadines?
Provide a succinct answer. -40.2. What is the ratio of the Total Labor Force (in %) in Belarus in 1995 to that in 1996?
Keep it short and to the point. 1.01. What is the ratio of the Total Labor Force (in %) in Iran in 1995 to that in 1996?
Keep it short and to the point. 0.98. What is the ratio of the Total Labor Force (in %) of St. Vincent and the Grenadines in 1995 to that in 1996?
Your response must be concise. 0.99. What is the ratio of the Total Labor Force (in %) in Belarus in 1995 to that in 1997?
Your answer should be very brief. 1.02. What is the ratio of the Total Labor Force (in %) of Iran in 1995 to that in 1997?
Give a very brief answer. 0.92. What is the ratio of the Total Labor Force (in %) in St. Vincent and the Grenadines in 1995 to that in 1997?
Offer a very short reply. 0.98. What is the ratio of the Total Labor Force (in %) of Belarus in 1995 to that in 1998?
Provide a succinct answer. 1.03. What is the ratio of the Total Labor Force (in %) in Equatorial Guinea in 1995 to that in 1998?
Ensure brevity in your answer.  1. What is the ratio of the Total Labor Force (in %) of Iran in 1995 to that in 1998?
Offer a very short reply. 0.86. What is the ratio of the Total Labor Force (in %) in St. Vincent and the Grenadines in 1995 to that in 1998?
Provide a succinct answer. 0.97. What is the ratio of the Total Labor Force (in %) in Belarus in 1995 to that in 1999?
Your response must be concise. 1.04. What is the ratio of the Total Labor Force (in %) in Equatorial Guinea in 1995 to that in 1999?
Provide a short and direct response. 1. What is the ratio of the Total Labor Force (in %) of Iran in 1995 to that in 1999?
Keep it short and to the point. 0.8. What is the ratio of the Total Labor Force (in %) of St. Vincent and the Grenadines in 1995 to that in 1999?
Offer a very short reply. 0.96. What is the ratio of the Total Labor Force (in %) of Belarus in 1995 to that in 2000?
Your answer should be very brief. 1.05. What is the ratio of the Total Labor Force (in %) in Iran in 1995 to that in 2000?
Offer a very short reply. 0.75. What is the ratio of the Total Labor Force (in %) in St. Vincent and the Grenadines in 1995 to that in 2000?
Offer a very short reply. 0.95. What is the ratio of the Total Labor Force (in %) in Belarus in 1995 to that in 2001?
Your answer should be compact. 1.05. What is the ratio of the Total Labor Force (in %) of Equatorial Guinea in 1995 to that in 2001?
Keep it short and to the point. 1.01. What is the ratio of the Total Labor Force (in %) of Iran in 1995 to that in 2001?
Ensure brevity in your answer.  0.71. What is the ratio of the Total Labor Force (in %) of St. Vincent and the Grenadines in 1995 to that in 2001?
Keep it short and to the point. 0.93. What is the ratio of the Total Labor Force (in %) in Belarus in 1995 to that in 2002?
Provide a succinct answer. 1.06. What is the ratio of the Total Labor Force (in %) of Equatorial Guinea in 1995 to that in 2002?
Make the answer very short. 1.01. What is the ratio of the Total Labor Force (in %) of Iran in 1995 to that in 2002?
Offer a terse response. 0.66. What is the ratio of the Total Labor Force (in %) of St. Vincent and the Grenadines in 1995 to that in 2002?
Offer a terse response. 0.92. What is the ratio of the Total Labor Force (in %) of Belarus in 1996 to that in 1997?
Give a very brief answer. 1.01. What is the ratio of the Total Labor Force (in %) of Equatorial Guinea in 1996 to that in 1997?
Offer a terse response. 1. What is the ratio of the Total Labor Force (in %) in Iran in 1996 to that in 1997?
Offer a very short reply. 0.93. What is the ratio of the Total Labor Force (in %) in Belarus in 1996 to that in 1998?
Your answer should be very brief. 1.02. What is the ratio of the Total Labor Force (in %) in Equatorial Guinea in 1996 to that in 1998?
Your answer should be very brief. 1. What is the ratio of the Total Labor Force (in %) in Iran in 1996 to that in 1998?
Give a very brief answer. 0.88. What is the ratio of the Total Labor Force (in %) of St. Vincent and the Grenadines in 1996 to that in 1998?
Your answer should be compact. 0.98. What is the ratio of the Total Labor Force (in %) of Equatorial Guinea in 1996 to that in 1999?
Your response must be concise. 1. What is the ratio of the Total Labor Force (in %) in Iran in 1996 to that in 1999?
Give a very brief answer. 0.82. What is the ratio of the Total Labor Force (in %) of St. Vincent and the Grenadines in 1996 to that in 1999?
Your answer should be very brief. 0.97. What is the ratio of the Total Labor Force (in %) in Belarus in 1996 to that in 2000?
Keep it short and to the point. 1.04. What is the ratio of the Total Labor Force (in %) of Equatorial Guinea in 1996 to that in 2000?
Provide a succinct answer. 1. What is the ratio of the Total Labor Force (in %) in Iran in 1996 to that in 2000?
Provide a succinct answer. 0.77. What is the ratio of the Total Labor Force (in %) in St. Vincent and the Grenadines in 1996 to that in 2000?
Give a very brief answer. 0.96. What is the ratio of the Total Labor Force (in %) in Belarus in 1996 to that in 2001?
Give a very brief answer. 1.04. What is the ratio of the Total Labor Force (in %) of Equatorial Guinea in 1996 to that in 2001?
Your answer should be very brief. 1. What is the ratio of the Total Labor Force (in %) of Iran in 1996 to that in 2001?
Your answer should be very brief. 0.72. What is the ratio of the Total Labor Force (in %) in St. Vincent and the Grenadines in 1996 to that in 2001?
Ensure brevity in your answer.  0.94. What is the ratio of the Total Labor Force (in %) of Belarus in 1996 to that in 2002?
Ensure brevity in your answer.  1.04. What is the ratio of the Total Labor Force (in %) of Iran in 1996 to that in 2002?
Provide a short and direct response. 0.67. What is the ratio of the Total Labor Force (in %) of St. Vincent and the Grenadines in 1996 to that in 2002?
Provide a succinct answer. 0.93. What is the ratio of the Total Labor Force (in %) of Belarus in 1997 to that in 1998?
Ensure brevity in your answer.  1.01. What is the ratio of the Total Labor Force (in %) in Equatorial Guinea in 1997 to that in 1998?
Provide a succinct answer. 1. What is the ratio of the Total Labor Force (in %) in Belarus in 1997 to that in 1999?
Provide a succinct answer. 1.02. What is the ratio of the Total Labor Force (in %) of Iran in 1997 to that in 1999?
Offer a very short reply. 0.88. What is the ratio of the Total Labor Force (in %) in St. Vincent and the Grenadines in 1997 to that in 1999?
Offer a very short reply. 0.98. What is the ratio of the Total Labor Force (in %) of Belarus in 1997 to that in 2000?
Your answer should be very brief. 1.03. What is the ratio of the Total Labor Force (in %) in Equatorial Guinea in 1997 to that in 2000?
Provide a short and direct response. 1. What is the ratio of the Total Labor Force (in %) in Iran in 1997 to that in 2000?
Ensure brevity in your answer.  0.82. What is the ratio of the Total Labor Force (in %) of St. Vincent and the Grenadines in 1997 to that in 2000?
Offer a terse response. 0.97. What is the ratio of the Total Labor Force (in %) in Belarus in 1997 to that in 2001?
Provide a short and direct response. 1.03. What is the ratio of the Total Labor Force (in %) in Equatorial Guinea in 1997 to that in 2001?
Your answer should be very brief. 1. What is the ratio of the Total Labor Force (in %) in Iran in 1997 to that in 2001?
Your response must be concise. 0.77. What is the ratio of the Total Labor Force (in %) in St. Vincent and the Grenadines in 1997 to that in 2001?
Keep it short and to the point. 0.96. What is the ratio of the Total Labor Force (in %) of Belarus in 1997 to that in 2002?
Your answer should be very brief. 1.03. What is the ratio of the Total Labor Force (in %) of Equatorial Guinea in 1997 to that in 2002?
Give a very brief answer. 1. What is the ratio of the Total Labor Force (in %) in Iran in 1997 to that in 2002?
Your answer should be compact. 0.72. What is the ratio of the Total Labor Force (in %) in St. Vincent and the Grenadines in 1997 to that in 2002?
Provide a short and direct response. 0.95. What is the ratio of the Total Labor Force (in %) of Belarus in 1998 to that in 1999?
Give a very brief answer. 1.01. What is the ratio of the Total Labor Force (in %) of Equatorial Guinea in 1998 to that in 1999?
Provide a succinct answer. 1. What is the ratio of the Total Labor Force (in %) in Iran in 1998 to that in 1999?
Your answer should be compact. 0.93. What is the ratio of the Total Labor Force (in %) in Belarus in 1998 to that in 2000?
Your answer should be very brief. 1.02. What is the ratio of the Total Labor Force (in %) of Iran in 1998 to that in 2000?
Offer a terse response. 0.88. What is the ratio of the Total Labor Force (in %) in St. Vincent and the Grenadines in 1998 to that in 2000?
Give a very brief answer. 0.98. What is the ratio of the Total Labor Force (in %) in Belarus in 1998 to that in 2001?
Make the answer very short. 1.02. What is the ratio of the Total Labor Force (in %) in Equatorial Guinea in 1998 to that in 2001?
Your response must be concise. 1. What is the ratio of the Total Labor Force (in %) in Iran in 1998 to that in 2001?
Ensure brevity in your answer.  0.82. What is the ratio of the Total Labor Force (in %) of St. Vincent and the Grenadines in 1998 to that in 2001?
Offer a very short reply. 0.97. What is the ratio of the Total Labor Force (in %) of Belarus in 1998 to that in 2002?
Your answer should be very brief. 1.02. What is the ratio of the Total Labor Force (in %) of Equatorial Guinea in 1998 to that in 2002?
Provide a short and direct response. 1. What is the ratio of the Total Labor Force (in %) of Iran in 1998 to that in 2002?
Your answer should be very brief. 0.77. What is the ratio of the Total Labor Force (in %) of St. Vincent and the Grenadines in 1998 to that in 2002?
Give a very brief answer. 0.95. What is the ratio of the Total Labor Force (in %) in Belarus in 1999 to that in 2000?
Provide a short and direct response. 1. What is the ratio of the Total Labor Force (in %) of Equatorial Guinea in 1999 to that in 2000?
Keep it short and to the point. 1. What is the ratio of the Total Labor Force (in %) of Iran in 1999 to that in 2000?
Your response must be concise. 0.94. What is the ratio of the Total Labor Force (in %) in Belarus in 1999 to that in 2001?
Provide a short and direct response. 1.01. What is the ratio of the Total Labor Force (in %) in Iran in 1999 to that in 2001?
Make the answer very short. 0.88. What is the ratio of the Total Labor Force (in %) in St. Vincent and the Grenadines in 1999 to that in 2001?
Offer a very short reply. 0.98. What is the ratio of the Total Labor Force (in %) in Belarus in 1999 to that in 2002?
Offer a very short reply. 1.01. What is the ratio of the Total Labor Force (in %) in Equatorial Guinea in 1999 to that in 2002?
Ensure brevity in your answer.  1. What is the ratio of the Total Labor Force (in %) of Iran in 1999 to that in 2002?
Ensure brevity in your answer.  0.82. What is the ratio of the Total Labor Force (in %) of St. Vincent and the Grenadines in 1999 to that in 2002?
Provide a short and direct response. 0.96. What is the ratio of the Total Labor Force (in %) in Belarus in 2000 to that in 2001?
Offer a very short reply. 1. What is the ratio of the Total Labor Force (in %) of Iran in 2000 to that in 2001?
Your response must be concise. 0.94. What is the ratio of the Total Labor Force (in %) in St. Vincent and the Grenadines in 2000 to that in 2001?
Make the answer very short. 0.99. What is the ratio of the Total Labor Force (in %) of Iran in 2000 to that in 2002?
Give a very brief answer. 0.87. What is the ratio of the Total Labor Force (in %) of St. Vincent and the Grenadines in 2000 to that in 2002?
Offer a terse response. 0.98. What is the ratio of the Total Labor Force (in %) of Belarus in 2001 to that in 2002?
Offer a terse response. 1. What is the ratio of the Total Labor Force (in %) of Equatorial Guinea in 2001 to that in 2002?
Your answer should be very brief. 1. What is the ratio of the Total Labor Force (in %) in Iran in 2001 to that in 2002?
Give a very brief answer. 0.93. What is the ratio of the Total Labor Force (in %) in St. Vincent and the Grenadines in 2001 to that in 2002?
Your answer should be very brief. 0.99. What is the difference between the highest and the second highest Total Labor Force (in %) of Belarus?
Give a very brief answer. 0.7. What is the difference between the highest and the second highest Total Labor Force (in %) of Equatorial Guinea?
Provide a succinct answer. 0.1. What is the difference between the highest and the second highest Total Labor Force (in %) in Iran?
Your answer should be very brief. 1.1. What is the difference between the highest and the second highest Total Labor Force (in %) in St. Vincent and the Grenadines?
Make the answer very short. 0.7. What is the difference between the highest and the lowest Total Labor Force (in %) in Equatorial Guinea?
Your answer should be very brief. 0.6. 